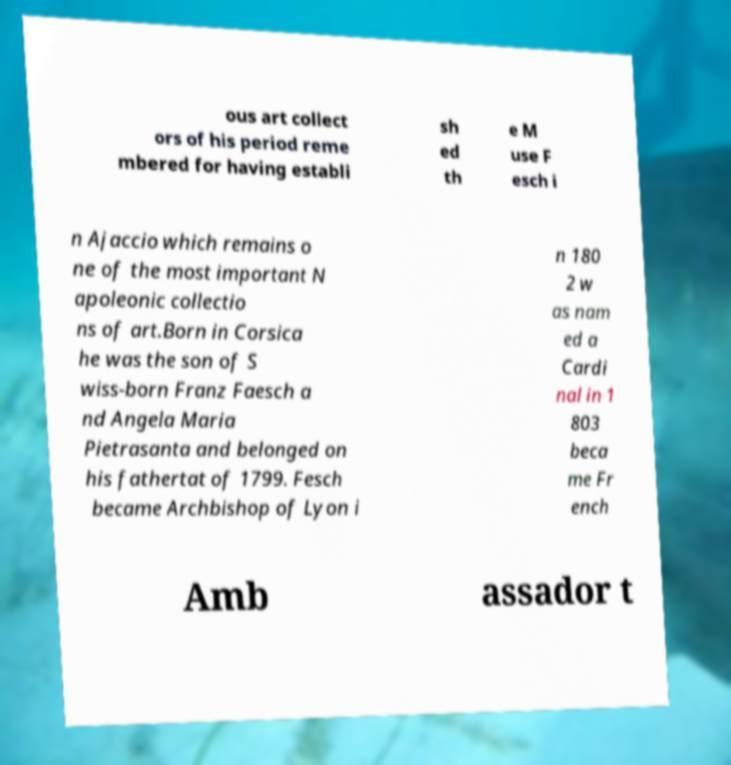Please read and relay the text visible in this image. What does it say? ous art collect ors of his period reme mbered for having establi sh ed th e M use F esch i n Ajaccio which remains o ne of the most important N apoleonic collectio ns of art.Born in Corsica he was the son of S wiss-born Franz Faesch a nd Angela Maria Pietrasanta and belonged on his fathertat of 1799. Fesch became Archbishop of Lyon i n 180 2 w as nam ed a Cardi nal in 1 803 beca me Fr ench Amb assador t 